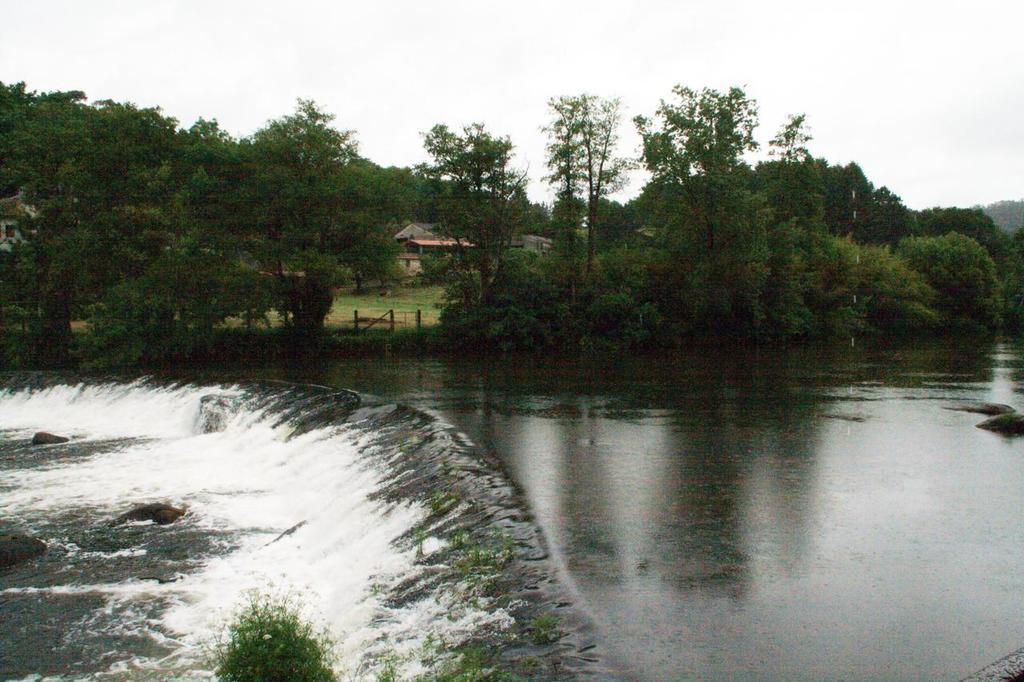What is the main feature in the center of the image? There is water in the center of the image. What can be seen in the background of the image? There are trees in the background of the image. What type of vegetation is present on the ground? There is grass on the ground. What type of structure is visible in the image? There is a house in the image. Where is the clam located in the image? There is no clam present in the image. What type of train can be seen passing by the house in the image? There is no train present in the image; it only features water, trees, grass, and a house. 